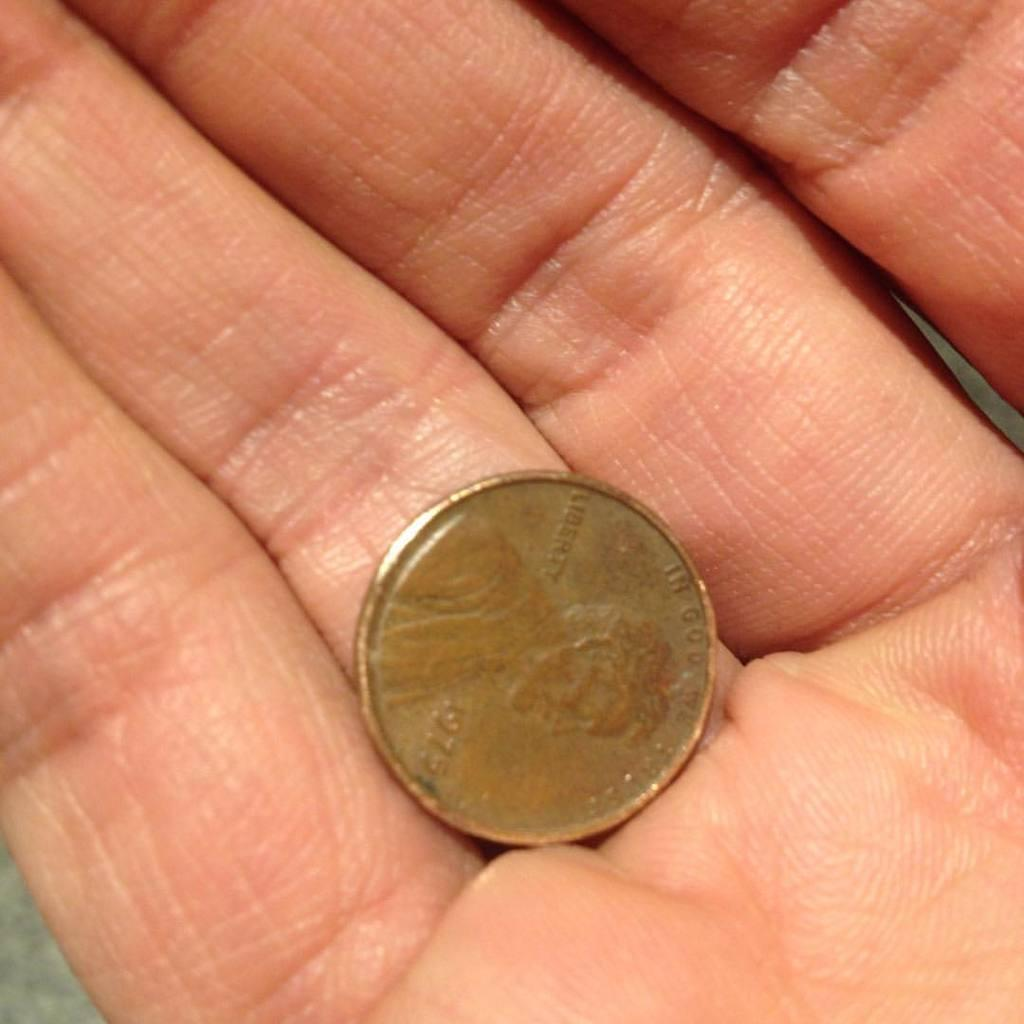<image>
Summarize the visual content of the image. A hand holding a United States Penny from 1975. 